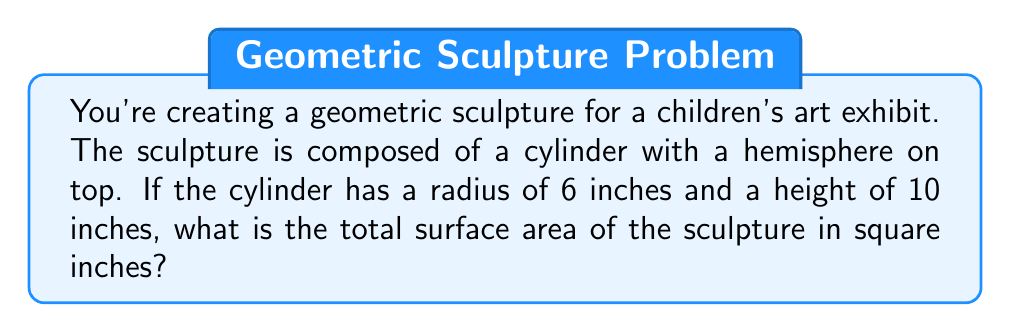Provide a solution to this math problem. Let's approach this step-by-step:

1) The sculpture consists of two parts: a cylinder and a hemisphere.

2) For the cylinder:
   - Lateral surface area: $A_l = 2\pi rh$
   - Base area: $A_b = \pi r^2$
   
3) For the hemisphere:
   - Surface area: $A_h = 2\pi r^2$

4) Calculate the cylinder's surface area:
   - Lateral: $A_l = 2\pi (6)(10) = 120\pi$ sq inches
   - Base: $A_b = \pi (6^2) = 36\pi$ sq inches
   - Total cylinder area: $A_c = 120\pi + 36\pi = 156\pi$ sq inches

5) Calculate the hemisphere's surface area:
   $A_h = 2\pi (6^2) = 72\pi$ sq inches

6) Sum the areas:
   Total surface area = Cylinder area + Hemisphere area
   $A_{total} = 156\pi + 72\pi = 228\pi$ sq inches

7) Simplify:
   $A_{total} = 228\pi \approx 716.28$ sq inches
Answer: $228\pi$ sq inches (or approximately 716.28 sq inches) 